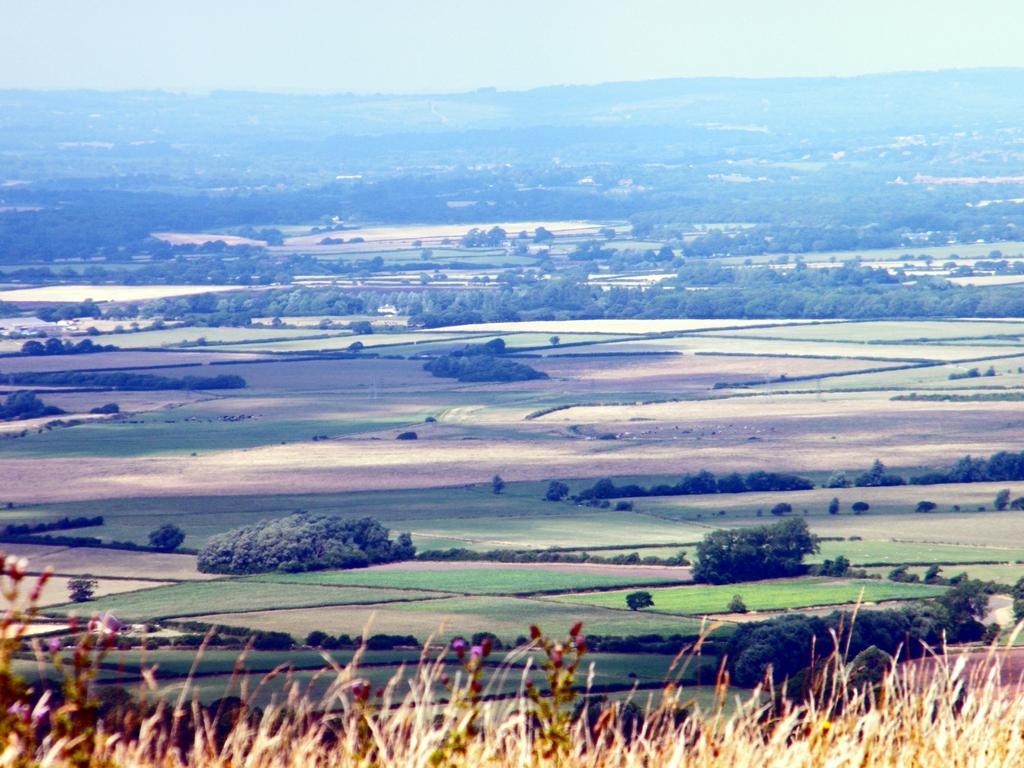Describe this image in one or two sentences. At the bottom of the image we can find few plants, in the background we can see trees. 